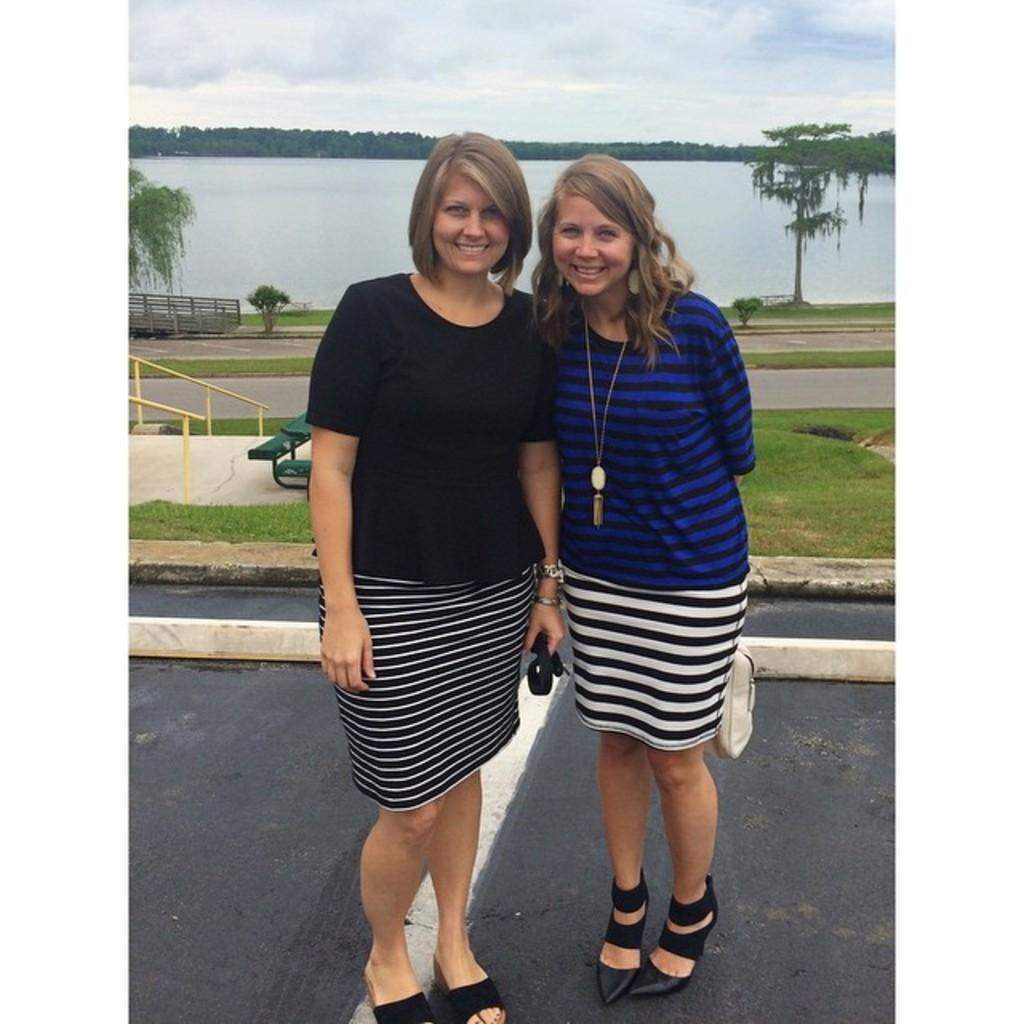How many women are in the image? There are two women in the image. Where are the women located in the image? The women are standing on the road in the image. What can be seen in the background of the image? In the background of the image, there are plants, a bench, trees, water, and a cloudy sky. What type of quiver can be seen on the women's backs in the image? There is no quiver present on the women's backs in the image. Where is the office located in the image? There is no office present in the image. 